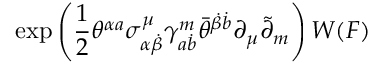<formula> <loc_0><loc_0><loc_500><loc_500>\exp \left ( \frac { 1 } { 2 } \theta ^ { \alpha a } \sigma _ { \alpha \dot { \beta } } ^ { \mu } \gamma _ { a \dot { b } } ^ { m } \bar { \theta } ^ { \dot { \beta } \dot { b } } \partial _ { \mu } \tilde { \partial } _ { m } \right ) W ( F )</formula> 